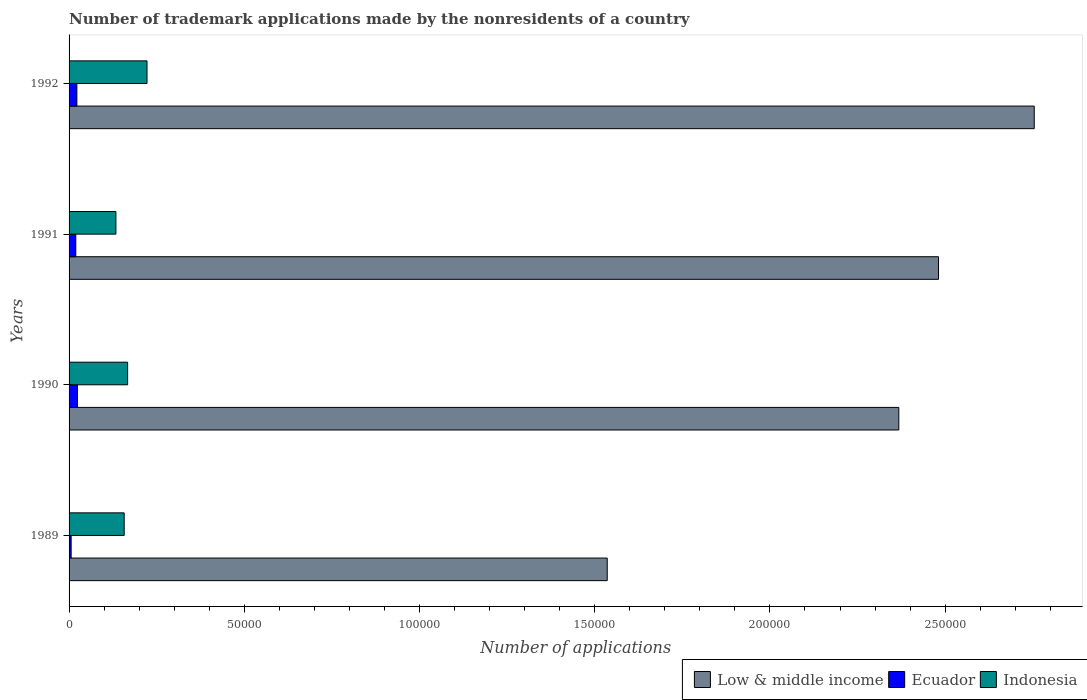How many groups of bars are there?
Make the answer very short. 4. How many bars are there on the 1st tick from the bottom?
Provide a short and direct response. 3. What is the label of the 2nd group of bars from the top?
Provide a succinct answer. 1991. In how many cases, is the number of bars for a given year not equal to the number of legend labels?
Offer a terse response. 0. What is the number of trademark applications made by the nonresidents in Low & middle income in 1989?
Give a very brief answer. 1.54e+05. Across all years, what is the maximum number of trademark applications made by the nonresidents in Ecuador?
Offer a very short reply. 2399. Across all years, what is the minimum number of trademark applications made by the nonresidents in Indonesia?
Make the answer very short. 1.34e+04. What is the total number of trademark applications made by the nonresidents in Ecuador in the graph?
Ensure brevity in your answer.  7134. What is the difference between the number of trademark applications made by the nonresidents in Ecuador in 1991 and that in 1992?
Provide a short and direct response. -308. What is the difference between the number of trademark applications made by the nonresidents in Indonesia in 1990 and the number of trademark applications made by the nonresidents in Low & middle income in 1991?
Give a very brief answer. -2.31e+05. What is the average number of trademark applications made by the nonresidents in Low & middle income per year?
Make the answer very short. 2.28e+05. In the year 1991, what is the difference between the number of trademark applications made by the nonresidents in Low & middle income and number of trademark applications made by the nonresidents in Ecuador?
Give a very brief answer. 2.46e+05. In how many years, is the number of trademark applications made by the nonresidents in Indonesia greater than 180000 ?
Your response must be concise. 0. What is the ratio of the number of trademark applications made by the nonresidents in Ecuador in 1989 to that in 1992?
Keep it short and to the point. 0.26. Is the number of trademark applications made by the nonresidents in Ecuador in 1990 less than that in 1991?
Provide a succinct answer. No. Is the difference between the number of trademark applications made by the nonresidents in Low & middle income in 1989 and 1991 greater than the difference between the number of trademark applications made by the nonresidents in Ecuador in 1989 and 1991?
Make the answer very short. No. What is the difference between the highest and the second highest number of trademark applications made by the nonresidents in Indonesia?
Provide a short and direct response. 5526. What is the difference between the highest and the lowest number of trademark applications made by the nonresidents in Indonesia?
Your answer should be compact. 8874. What does the 2nd bar from the top in 1991 represents?
Give a very brief answer. Ecuador. What does the 2nd bar from the bottom in 1989 represents?
Offer a terse response. Ecuador. Is it the case that in every year, the sum of the number of trademark applications made by the nonresidents in Low & middle income and number of trademark applications made by the nonresidents in Ecuador is greater than the number of trademark applications made by the nonresidents in Indonesia?
Offer a terse response. Yes. How many bars are there?
Make the answer very short. 12. Are all the bars in the graph horizontal?
Offer a terse response. Yes. How many years are there in the graph?
Keep it short and to the point. 4. Are the values on the major ticks of X-axis written in scientific E-notation?
Give a very brief answer. No. Does the graph contain any zero values?
Provide a short and direct response. No. Where does the legend appear in the graph?
Keep it short and to the point. Bottom right. How many legend labels are there?
Your answer should be very brief. 3. How are the legend labels stacked?
Give a very brief answer. Horizontal. What is the title of the graph?
Give a very brief answer. Number of trademark applications made by the nonresidents of a country. Does "American Samoa" appear as one of the legend labels in the graph?
Your answer should be very brief. No. What is the label or title of the X-axis?
Give a very brief answer. Number of applications. What is the label or title of the Y-axis?
Keep it short and to the point. Years. What is the Number of applications in Low & middle income in 1989?
Keep it short and to the point. 1.54e+05. What is the Number of applications of Ecuador in 1989?
Provide a succinct answer. 589. What is the Number of applications in Indonesia in 1989?
Keep it short and to the point. 1.57e+04. What is the Number of applications in Low & middle income in 1990?
Offer a terse response. 2.37e+05. What is the Number of applications in Ecuador in 1990?
Your response must be concise. 2399. What is the Number of applications in Indonesia in 1990?
Your response must be concise. 1.67e+04. What is the Number of applications of Low & middle income in 1991?
Provide a short and direct response. 2.48e+05. What is the Number of applications of Ecuador in 1991?
Your response must be concise. 1919. What is the Number of applications of Indonesia in 1991?
Make the answer very short. 1.34e+04. What is the Number of applications of Low & middle income in 1992?
Provide a succinct answer. 2.75e+05. What is the Number of applications in Ecuador in 1992?
Offer a terse response. 2227. What is the Number of applications of Indonesia in 1992?
Your answer should be very brief. 2.22e+04. Across all years, what is the maximum Number of applications of Low & middle income?
Offer a very short reply. 2.75e+05. Across all years, what is the maximum Number of applications in Ecuador?
Your answer should be very brief. 2399. Across all years, what is the maximum Number of applications of Indonesia?
Your answer should be very brief. 2.22e+04. Across all years, what is the minimum Number of applications in Low & middle income?
Your response must be concise. 1.54e+05. Across all years, what is the minimum Number of applications of Ecuador?
Provide a succinct answer. 589. Across all years, what is the minimum Number of applications of Indonesia?
Your answer should be very brief. 1.34e+04. What is the total Number of applications of Low & middle income in the graph?
Offer a terse response. 9.14e+05. What is the total Number of applications of Ecuador in the graph?
Your answer should be very brief. 7134. What is the total Number of applications of Indonesia in the graph?
Offer a terse response. 6.80e+04. What is the difference between the Number of applications of Low & middle income in 1989 and that in 1990?
Provide a short and direct response. -8.32e+04. What is the difference between the Number of applications of Ecuador in 1989 and that in 1990?
Ensure brevity in your answer.  -1810. What is the difference between the Number of applications in Indonesia in 1989 and that in 1990?
Make the answer very short. -983. What is the difference between the Number of applications of Low & middle income in 1989 and that in 1991?
Your response must be concise. -9.45e+04. What is the difference between the Number of applications of Ecuador in 1989 and that in 1991?
Make the answer very short. -1330. What is the difference between the Number of applications of Indonesia in 1989 and that in 1991?
Offer a terse response. 2365. What is the difference between the Number of applications in Low & middle income in 1989 and that in 1992?
Provide a short and direct response. -1.22e+05. What is the difference between the Number of applications of Ecuador in 1989 and that in 1992?
Keep it short and to the point. -1638. What is the difference between the Number of applications of Indonesia in 1989 and that in 1992?
Make the answer very short. -6509. What is the difference between the Number of applications in Low & middle income in 1990 and that in 1991?
Provide a succinct answer. -1.13e+04. What is the difference between the Number of applications in Ecuador in 1990 and that in 1991?
Your response must be concise. 480. What is the difference between the Number of applications in Indonesia in 1990 and that in 1991?
Your response must be concise. 3348. What is the difference between the Number of applications in Low & middle income in 1990 and that in 1992?
Provide a succinct answer. -3.86e+04. What is the difference between the Number of applications in Ecuador in 1990 and that in 1992?
Provide a short and direct response. 172. What is the difference between the Number of applications in Indonesia in 1990 and that in 1992?
Provide a short and direct response. -5526. What is the difference between the Number of applications in Low & middle income in 1991 and that in 1992?
Give a very brief answer. -2.73e+04. What is the difference between the Number of applications in Ecuador in 1991 and that in 1992?
Offer a very short reply. -308. What is the difference between the Number of applications of Indonesia in 1991 and that in 1992?
Ensure brevity in your answer.  -8874. What is the difference between the Number of applications in Low & middle income in 1989 and the Number of applications in Ecuador in 1990?
Make the answer very short. 1.51e+05. What is the difference between the Number of applications of Low & middle income in 1989 and the Number of applications of Indonesia in 1990?
Offer a terse response. 1.37e+05. What is the difference between the Number of applications of Ecuador in 1989 and the Number of applications of Indonesia in 1990?
Offer a terse response. -1.61e+04. What is the difference between the Number of applications in Low & middle income in 1989 and the Number of applications in Ecuador in 1991?
Make the answer very short. 1.52e+05. What is the difference between the Number of applications in Low & middle income in 1989 and the Number of applications in Indonesia in 1991?
Ensure brevity in your answer.  1.40e+05. What is the difference between the Number of applications in Ecuador in 1989 and the Number of applications in Indonesia in 1991?
Make the answer very short. -1.28e+04. What is the difference between the Number of applications of Low & middle income in 1989 and the Number of applications of Ecuador in 1992?
Offer a very short reply. 1.51e+05. What is the difference between the Number of applications in Low & middle income in 1989 and the Number of applications in Indonesia in 1992?
Keep it short and to the point. 1.31e+05. What is the difference between the Number of applications in Ecuador in 1989 and the Number of applications in Indonesia in 1992?
Keep it short and to the point. -2.16e+04. What is the difference between the Number of applications in Low & middle income in 1990 and the Number of applications in Ecuador in 1991?
Your answer should be very brief. 2.35e+05. What is the difference between the Number of applications of Low & middle income in 1990 and the Number of applications of Indonesia in 1991?
Offer a very short reply. 2.23e+05. What is the difference between the Number of applications in Ecuador in 1990 and the Number of applications in Indonesia in 1991?
Offer a terse response. -1.10e+04. What is the difference between the Number of applications of Low & middle income in 1990 and the Number of applications of Ecuador in 1992?
Ensure brevity in your answer.  2.35e+05. What is the difference between the Number of applications of Low & middle income in 1990 and the Number of applications of Indonesia in 1992?
Offer a very short reply. 2.15e+05. What is the difference between the Number of applications of Ecuador in 1990 and the Number of applications of Indonesia in 1992?
Provide a short and direct response. -1.98e+04. What is the difference between the Number of applications of Low & middle income in 1991 and the Number of applications of Ecuador in 1992?
Give a very brief answer. 2.46e+05. What is the difference between the Number of applications of Low & middle income in 1991 and the Number of applications of Indonesia in 1992?
Offer a terse response. 2.26e+05. What is the difference between the Number of applications in Ecuador in 1991 and the Number of applications in Indonesia in 1992?
Your answer should be very brief. -2.03e+04. What is the average Number of applications of Low & middle income per year?
Offer a terse response. 2.28e+05. What is the average Number of applications of Ecuador per year?
Your answer should be compact. 1783.5. What is the average Number of applications of Indonesia per year?
Your answer should be very brief. 1.70e+04. In the year 1989, what is the difference between the Number of applications in Low & middle income and Number of applications in Ecuador?
Your answer should be very brief. 1.53e+05. In the year 1989, what is the difference between the Number of applications of Low & middle income and Number of applications of Indonesia?
Give a very brief answer. 1.38e+05. In the year 1989, what is the difference between the Number of applications of Ecuador and Number of applications of Indonesia?
Give a very brief answer. -1.51e+04. In the year 1990, what is the difference between the Number of applications in Low & middle income and Number of applications in Ecuador?
Offer a very short reply. 2.34e+05. In the year 1990, what is the difference between the Number of applications of Low & middle income and Number of applications of Indonesia?
Give a very brief answer. 2.20e+05. In the year 1990, what is the difference between the Number of applications in Ecuador and Number of applications in Indonesia?
Give a very brief answer. -1.43e+04. In the year 1991, what is the difference between the Number of applications in Low & middle income and Number of applications in Ecuador?
Provide a succinct answer. 2.46e+05. In the year 1991, what is the difference between the Number of applications of Low & middle income and Number of applications of Indonesia?
Ensure brevity in your answer.  2.35e+05. In the year 1991, what is the difference between the Number of applications in Ecuador and Number of applications in Indonesia?
Provide a short and direct response. -1.14e+04. In the year 1992, what is the difference between the Number of applications in Low & middle income and Number of applications in Ecuador?
Provide a succinct answer. 2.73e+05. In the year 1992, what is the difference between the Number of applications in Low & middle income and Number of applications in Indonesia?
Your answer should be compact. 2.53e+05. In the year 1992, what is the difference between the Number of applications of Ecuador and Number of applications of Indonesia?
Provide a short and direct response. -2.00e+04. What is the ratio of the Number of applications in Low & middle income in 1989 to that in 1990?
Keep it short and to the point. 0.65. What is the ratio of the Number of applications in Ecuador in 1989 to that in 1990?
Offer a very short reply. 0.25. What is the ratio of the Number of applications in Low & middle income in 1989 to that in 1991?
Ensure brevity in your answer.  0.62. What is the ratio of the Number of applications of Ecuador in 1989 to that in 1991?
Your answer should be compact. 0.31. What is the ratio of the Number of applications in Indonesia in 1989 to that in 1991?
Your answer should be very brief. 1.18. What is the ratio of the Number of applications of Low & middle income in 1989 to that in 1992?
Provide a short and direct response. 0.56. What is the ratio of the Number of applications in Ecuador in 1989 to that in 1992?
Keep it short and to the point. 0.26. What is the ratio of the Number of applications in Indonesia in 1989 to that in 1992?
Provide a short and direct response. 0.71. What is the ratio of the Number of applications in Low & middle income in 1990 to that in 1991?
Offer a very short reply. 0.95. What is the ratio of the Number of applications of Ecuador in 1990 to that in 1991?
Keep it short and to the point. 1.25. What is the ratio of the Number of applications in Indonesia in 1990 to that in 1991?
Offer a very short reply. 1.25. What is the ratio of the Number of applications in Low & middle income in 1990 to that in 1992?
Provide a succinct answer. 0.86. What is the ratio of the Number of applications in Ecuador in 1990 to that in 1992?
Make the answer very short. 1.08. What is the ratio of the Number of applications in Indonesia in 1990 to that in 1992?
Provide a succinct answer. 0.75. What is the ratio of the Number of applications in Low & middle income in 1991 to that in 1992?
Offer a terse response. 0.9. What is the ratio of the Number of applications of Ecuador in 1991 to that in 1992?
Your answer should be very brief. 0.86. What is the ratio of the Number of applications of Indonesia in 1991 to that in 1992?
Ensure brevity in your answer.  0.6. What is the difference between the highest and the second highest Number of applications in Low & middle income?
Offer a terse response. 2.73e+04. What is the difference between the highest and the second highest Number of applications of Ecuador?
Make the answer very short. 172. What is the difference between the highest and the second highest Number of applications of Indonesia?
Offer a terse response. 5526. What is the difference between the highest and the lowest Number of applications in Low & middle income?
Offer a very short reply. 1.22e+05. What is the difference between the highest and the lowest Number of applications of Ecuador?
Provide a short and direct response. 1810. What is the difference between the highest and the lowest Number of applications of Indonesia?
Your answer should be compact. 8874. 